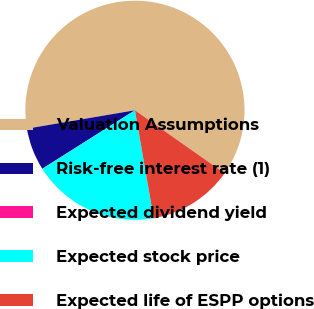<chart> <loc_0><loc_0><loc_500><loc_500><pie_chart><fcel>Valuation Assumptions<fcel>Risk-free interest rate (1)<fcel>Expected dividend yield<fcel>Expected stock price<fcel>Expected life of ESPP options<nl><fcel>62.43%<fcel>6.27%<fcel>0.03%<fcel>18.75%<fcel>12.51%<nl></chart> 